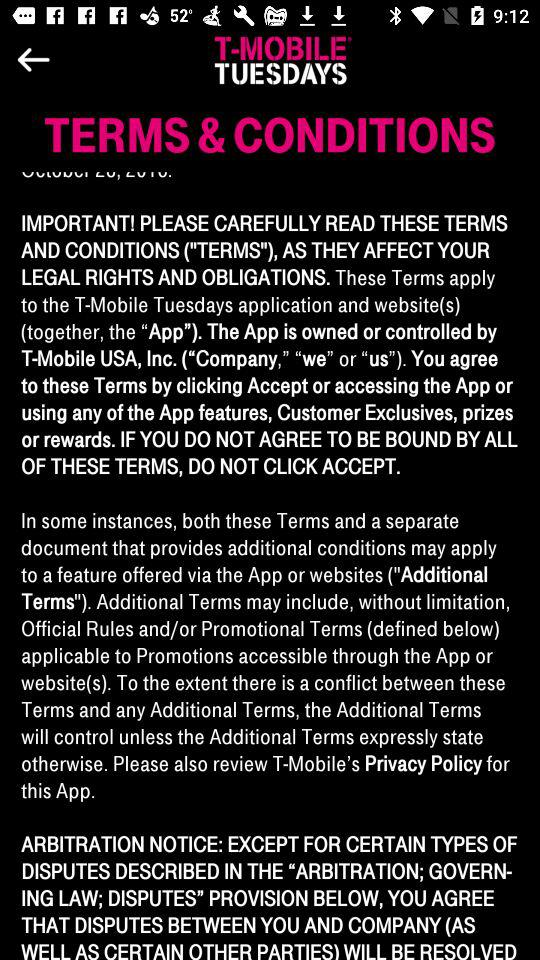What is the application name? The application name is "T-MOBILE® TUESDAYS". 